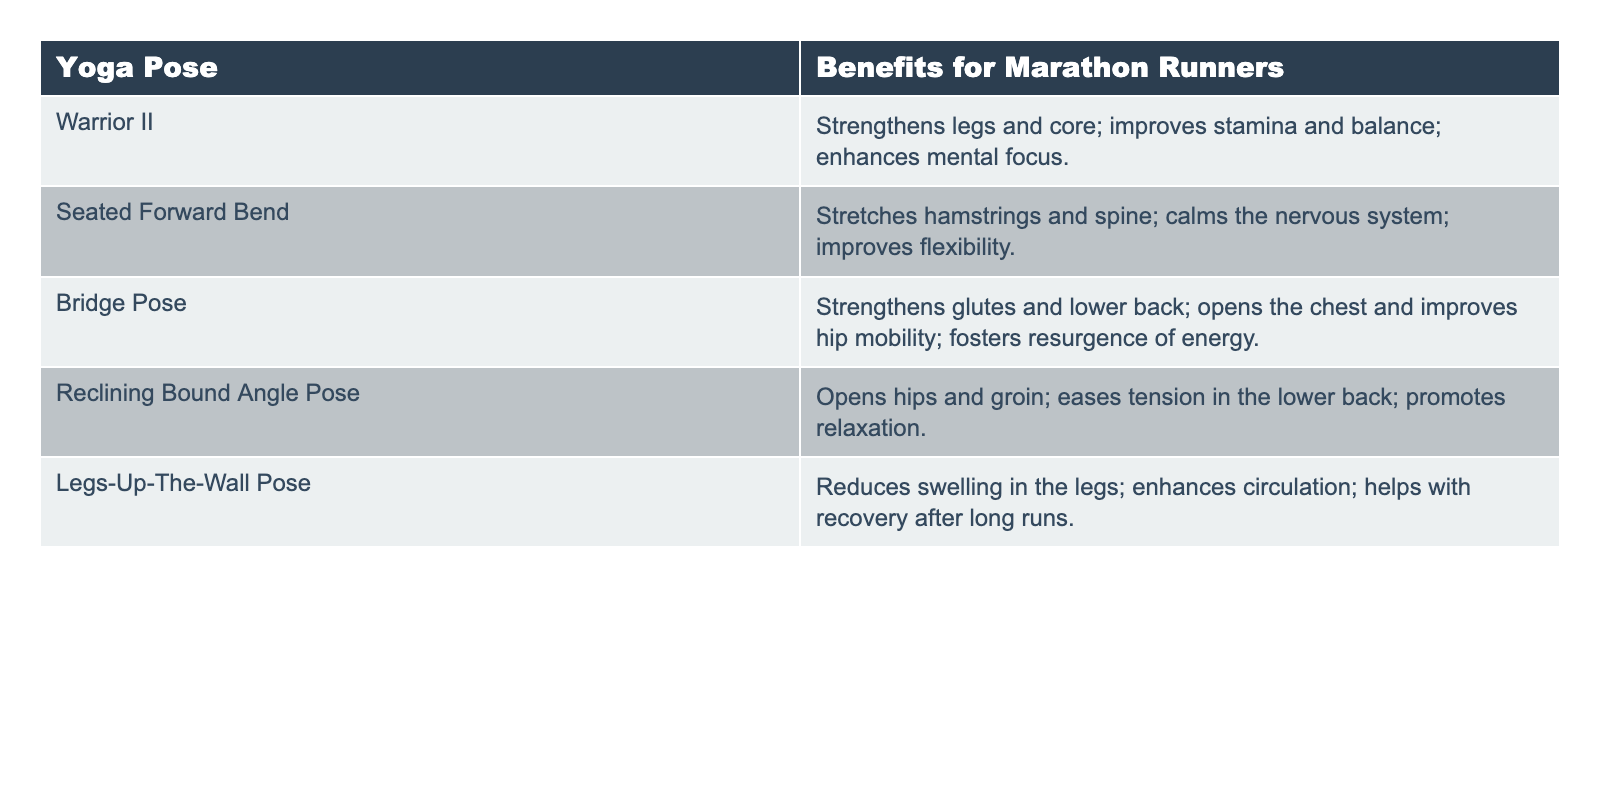What benefits does the Warrior II pose provide for marathon runners? According to the table, the benefits listed for Warrior II include strengthening the legs and core, improving stamina and balance, and enhancing mental focus.
Answer: Strengthens legs and core; improves stamina and balance; enhances mental focus Which yoga pose is designed to stretch the hamstrings and spine? The table indicates that the Seated Forward Bend is specifically noted for stretching the hamstrings and spine.
Answer: Seated Forward Bend How many yoga poses listed help with flexibility? There are two yoga poses specifically mentioned for improving flexibility: Seated Forward Bend and Reclining Bound Angle Pose. Thus, the total count is two.
Answer: Two Does the Bridge Pose contribute to energy resurgence? Yes, according to the table, one of the benefits of the Bridge Pose is fostering a resurgence of energy.
Answer: Yes Which pose has benefits related to the hips and groin? The table states that the Reclining Bound Angle Pose opens the hips and groin, indicating its benefits in that area.
Answer: Reclining Bound Angle Pose What is the primary benefit of Legs-Up-The-Wall Pose for marathon runners? The primary benefits listed for the Legs-Up-The-Wall Pose are reducing swelling in the legs, enhancing circulation, and aiding recovery after long runs, with all these being crucial for marathon runners.
Answer: Reduces swelling in the legs; enhances circulation; helps with recovery after long runs How many poses focus on both strengthening and flexibility improvement? The poses that focus on both strengthening and flexibility improvement are Warrior II, Bridge Pose, and Seated Forward Bend. Thus, the total count is three.
Answer: Three Does any pose specifically promote relaxation? Yes, the Reclining Bound Angle Pose is mentioned as promoting relaxation in the table.
Answer: Yes Which pose offers benefits for the lower back? The Bridge Pose and the Reclining Bound Angle Pose both offer benefits for the lower back, as specified in their descriptions.
Answer: Bridge Pose and Reclining Bound Angle Pose What is the difference in focus between Warrior II and Legs-Up-The-Wall Pose? Warrior II focuses on strengthening and stamina, while Legs-Up-The-Wall Pose focuses on recovery and circulation; they serve different needs for marathon runners.
Answer: Strength vs. recovery 